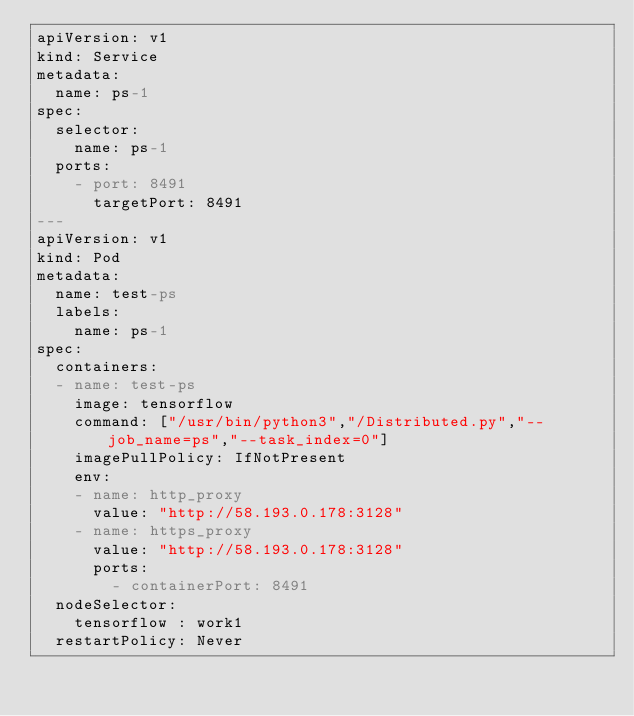<code> <loc_0><loc_0><loc_500><loc_500><_YAML_>apiVersion: v1
kind: Service
metadata: 
  name: ps-1
spec:
  selector:
    name: ps-1
  ports:
    - port: 8491
      targetPort: 8491
---
apiVersion: v1
kind: Pod
metadata:
  name: test-ps
  labels: 
    name: ps-1
spec:
  containers:
  - name: test-ps
    image: tensorflow
    command: ["/usr/bin/python3","/Distributed.py","--job_name=ps","--task_index=0"]
    imagePullPolicy: IfNotPresent
    env:
    - name: http_proxy
      value: "http://58.193.0.178:3128"
    - name: https_proxy
      value: "http://58.193.0.178:3128"
      ports:
        - containerPort: 8491
  nodeSelector: 
    tensorflow : work1
  restartPolicy: Never  
</code> 